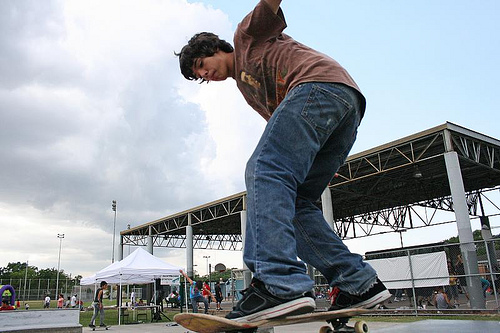<image>
Is there a tent above the table? Yes. The tent is positioned above the table in the vertical space, higher up in the scene. 